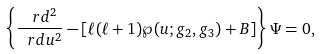<formula> <loc_0><loc_0><loc_500><loc_500>\left \{ \frac { \ r d ^ { 2 } } { \ r d u ^ { 2 } } - \left [ \ell ( \ell + 1 ) \wp ( u ; g _ { 2 } , g _ { 3 } ) + B \right ] \right \} \Psi = 0 ,</formula> 